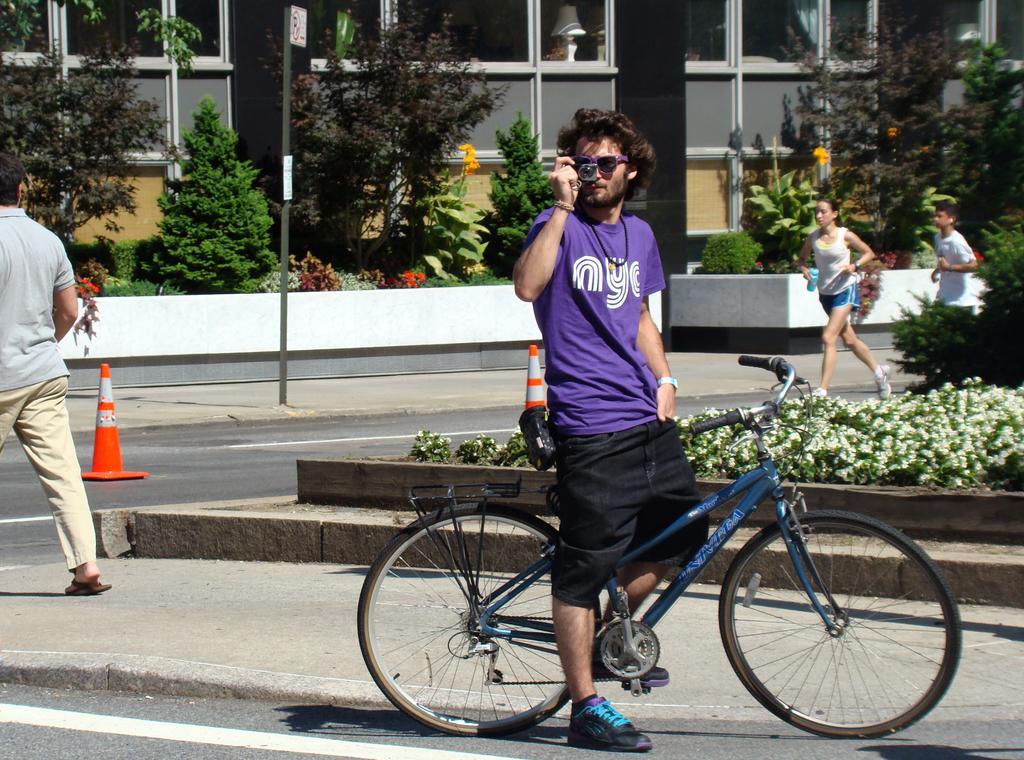Could you give a brief overview of what you see in this image? This is the picture of a person wearing blue shirt and black short and taking the picture who i son the bicycle and behind him there are some plants and other two ladies walking. 